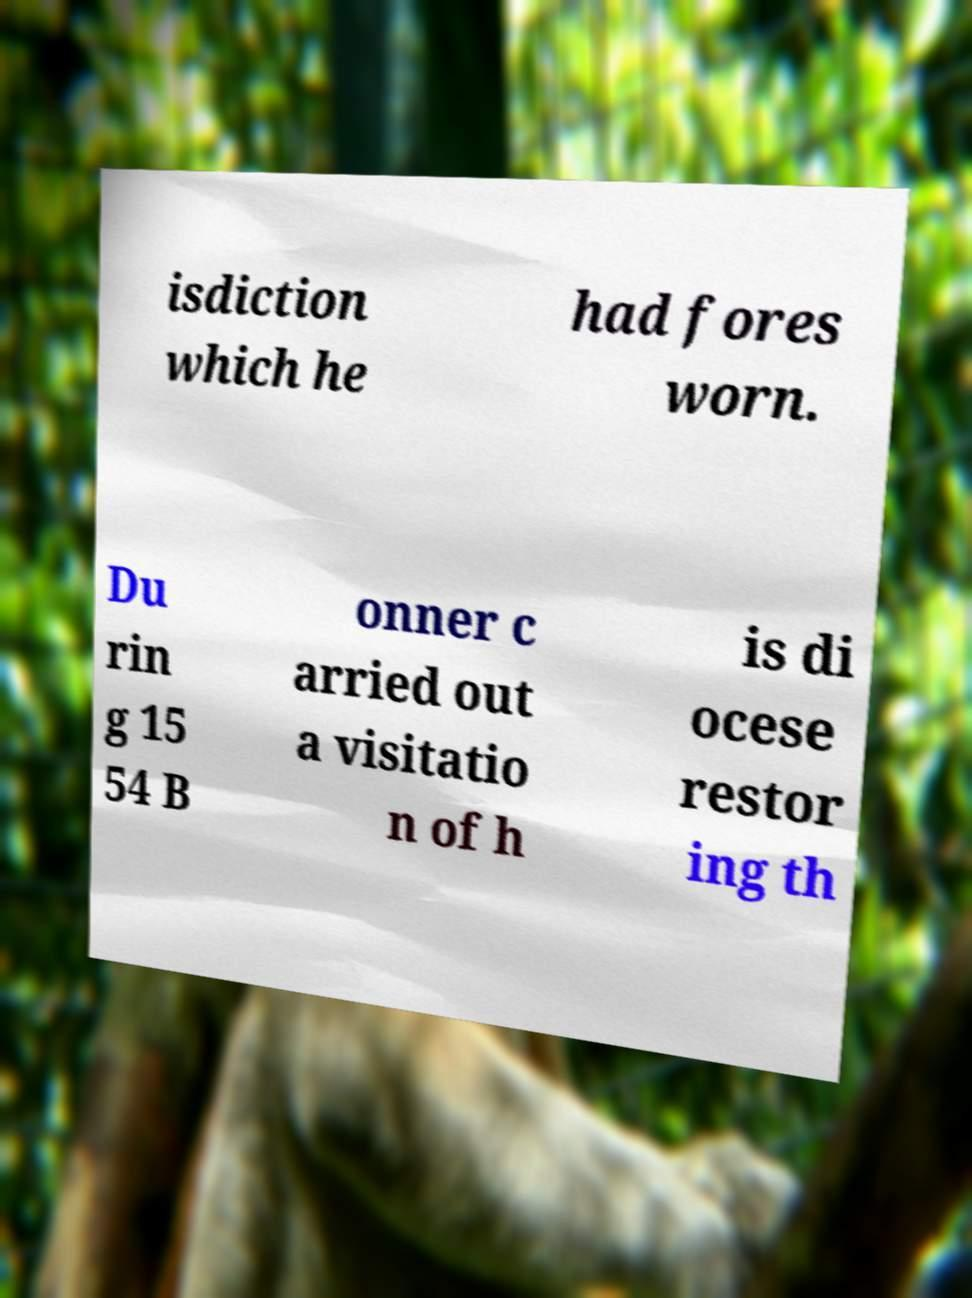What messages or text are displayed in this image? I need them in a readable, typed format. isdiction which he had fores worn. Du rin g 15 54 B onner c arried out a visitatio n of h is di ocese restor ing th 